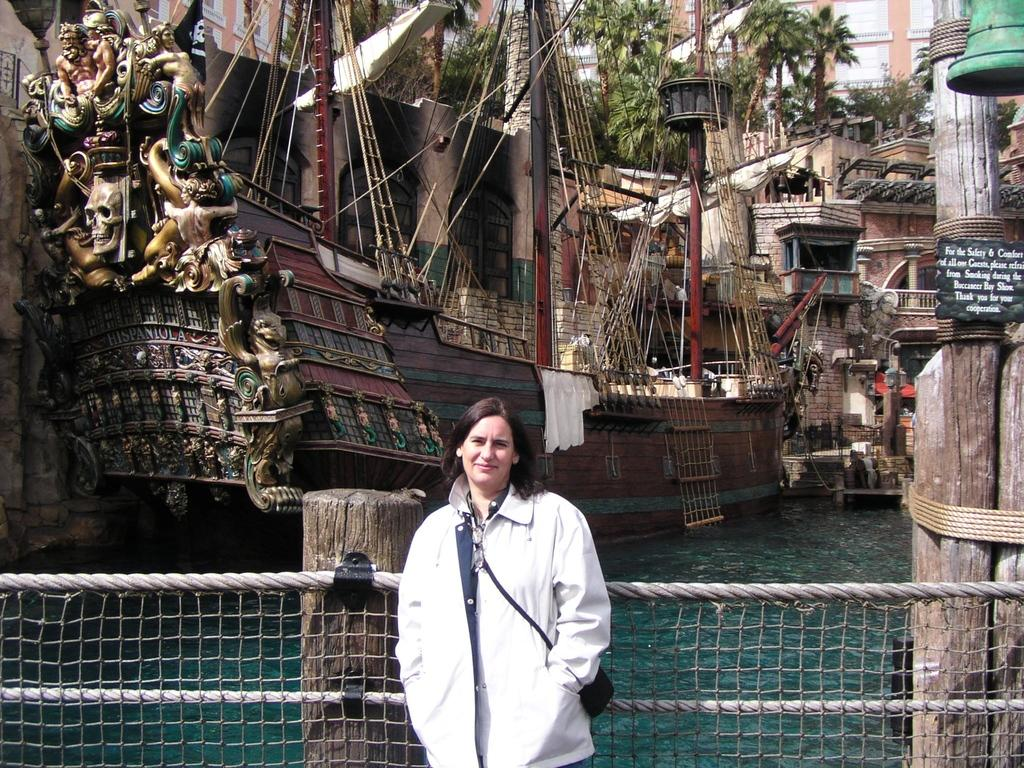What is the main subject in the center of the image? There are boats in the center of the image. What type of natural elements can be seen in the image? Trees are present in the image. What type of man-made structures are visible in the image? Buildings are visible in the image. What is the primary body of water in the image? There is water in the image. Can you describe the lady standing at the bottom of the image? A lady is standing at the bottom of the image. What materials are present at the bottom of the image? Mesh and wooden trucks are present at the bottom of the image. How many steel bars are visible in the image? There is no mention of steel bars in the image, so it is not possible to determine their presence or quantity. 